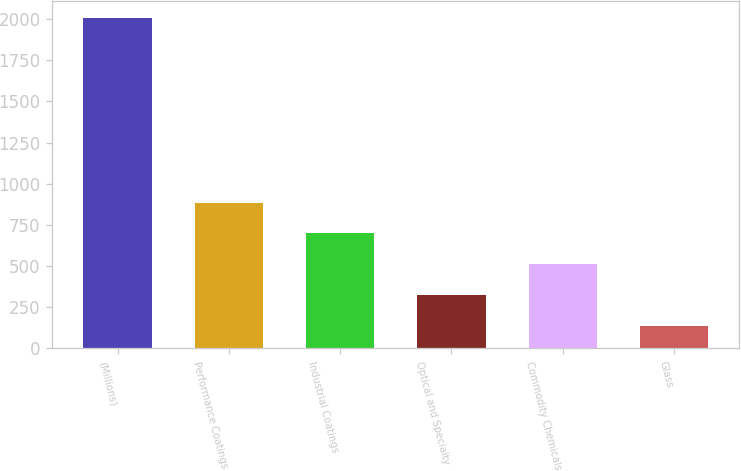<chart> <loc_0><loc_0><loc_500><loc_500><bar_chart><fcel>(Millions)<fcel>Performance Coatings<fcel>Industrial Coatings<fcel>Optical and Specialty<fcel>Commodity Chemicals<fcel>Glass<nl><fcel>2007<fcel>885.6<fcel>698.7<fcel>324.9<fcel>511.8<fcel>138<nl></chart> 